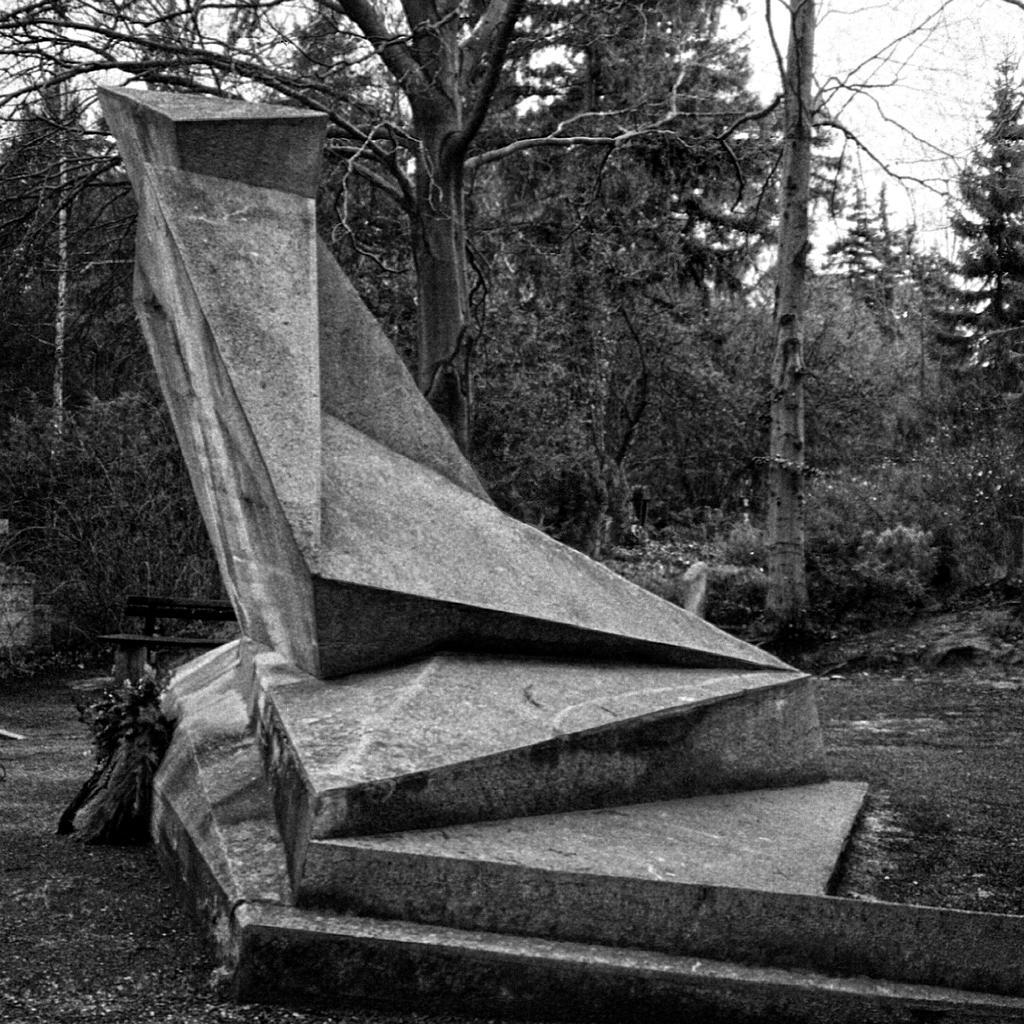What is the main subject in the image? There is a statue in the image. What can be seen behind the statue? There is a group of trees visible on the backside of the statue. What type of seating is present in the image? There is a bench in the image. What part of the trees is visible? The bark of the trees is visible. What other object can be seen in the image? There is a pole in the image. What is visible in the background of the image? The sky is visible in the image. Where is the room located in the image? There is no room present in the image; it features a statue, trees, a bench, a pole, and the sky. What type of teaching is being conducted in the image? There is no teaching activity present in the image; it is a scene with a statue, trees, a bench, a pole, and the sky. 